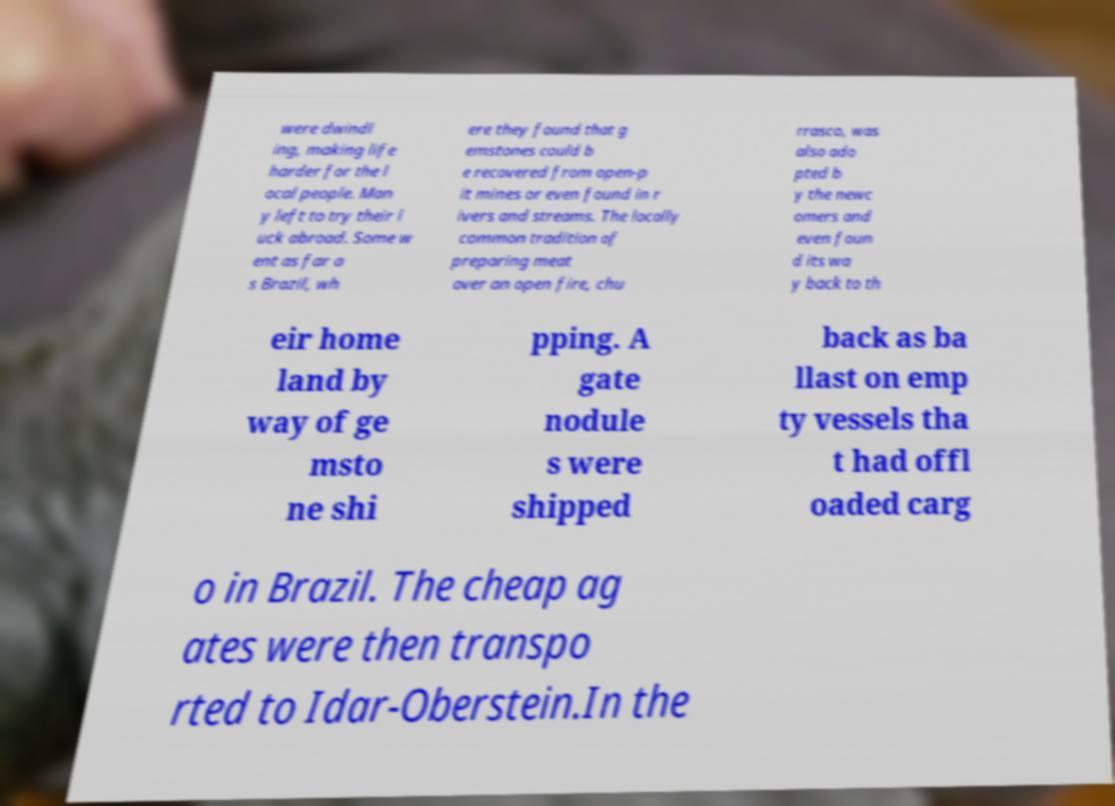Please identify and transcribe the text found in this image. were dwindl ing, making life harder for the l ocal people. Man y left to try their l uck abroad. Some w ent as far a s Brazil, wh ere they found that g emstones could b e recovered from open-p it mines or even found in r ivers and streams. The locally common tradition of preparing meat over an open fire, chu rrasco, was also ado pted b y the newc omers and even foun d its wa y back to th eir home land by way of ge msto ne shi pping. A gate nodule s were shipped back as ba llast on emp ty vessels tha t had offl oaded carg o in Brazil. The cheap ag ates were then transpo rted to Idar-Oberstein.In the 